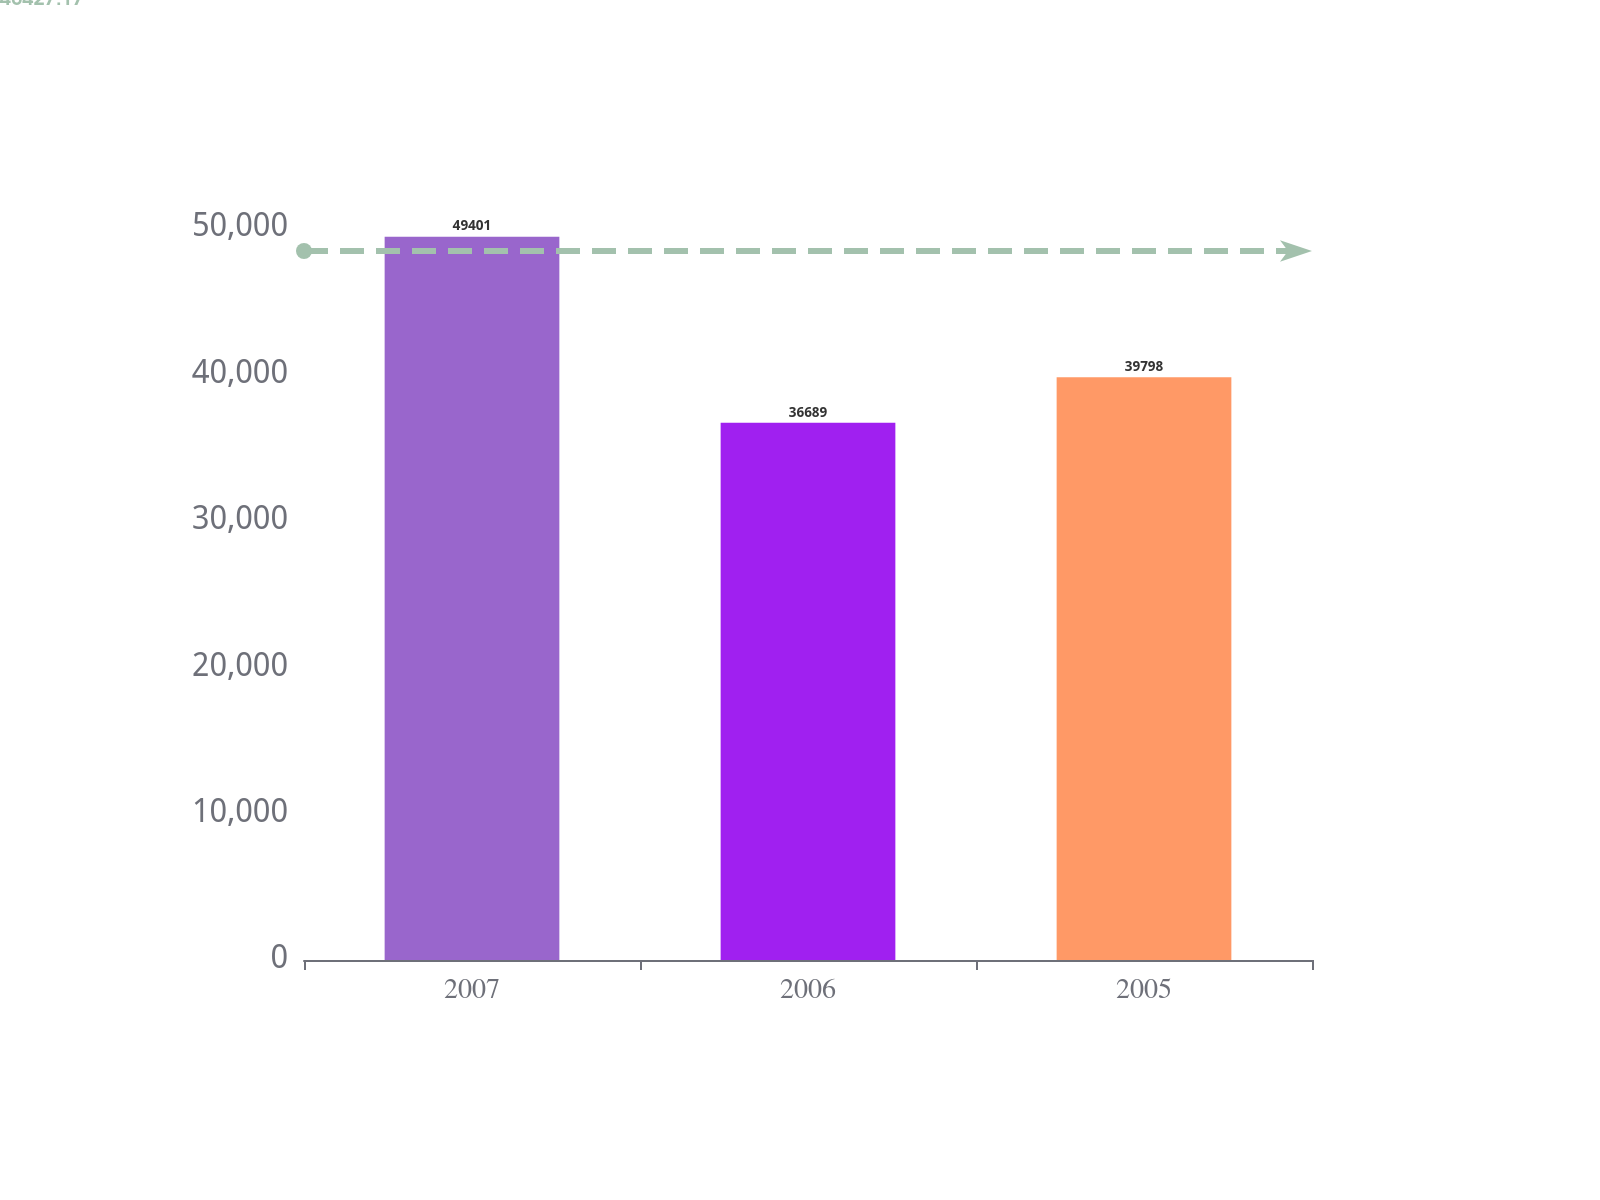Convert chart. <chart><loc_0><loc_0><loc_500><loc_500><bar_chart><fcel>2007<fcel>2006<fcel>2005<nl><fcel>49401<fcel>36689<fcel>39798<nl></chart> 